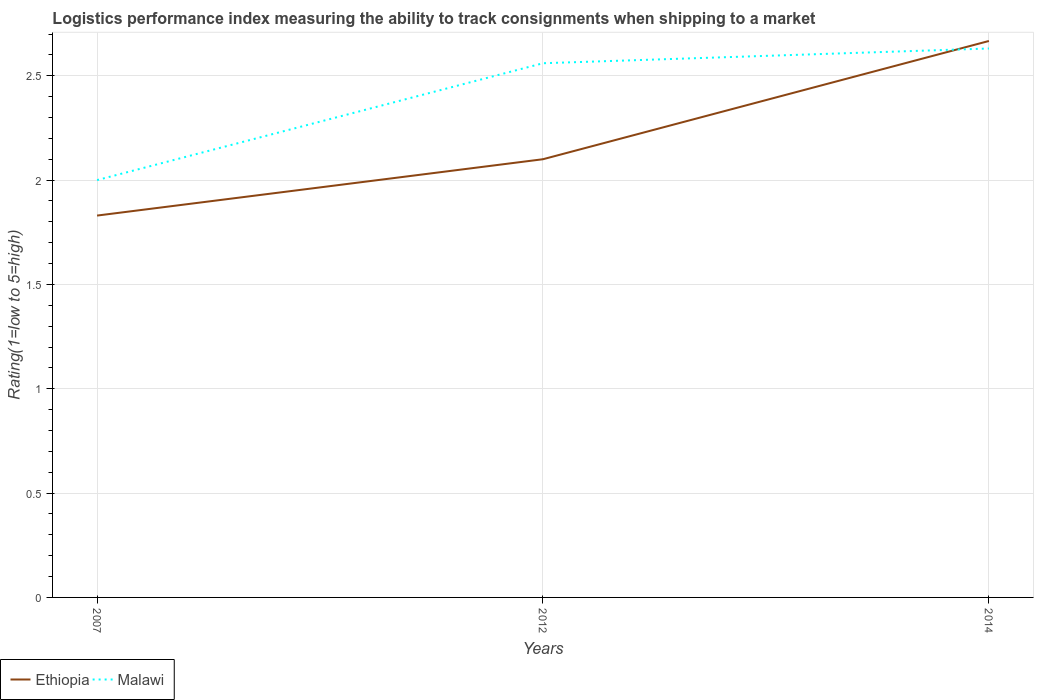Does the line corresponding to Malawi intersect with the line corresponding to Ethiopia?
Offer a very short reply. Yes. Is the number of lines equal to the number of legend labels?
Your answer should be very brief. Yes. Across all years, what is the maximum Logistic performance index in Ethiopia?
Offer a terse response. 1.83. What is the total Logistic performance index in Malawi in the graph?
Your answer should be very brief. -0.56. What is the difference between the highest and the second highest Logistic performance index in Ethiopia?
Your answer should be very brief. 0.84. Is the Logistic performance index in Malawi strictly greater than the Logistic performance index in Ethiopia over the years?
Your answer should be very brief. No. How many lines are there?
Provide a short and direct response. 2. How many years are there in the graph?
Give a very brief answer. 3. What is the difference between two consecutive major ticks on the Y-axis?
Make the answer very short. 0.5. Where does the legend appear in the graph?
Ensure brevity in your answer.  Bottom left. How many legend labels are there?
Make the answer very short. 2. How are the legend labels stacked?
Ensure brevity in your answer.  Horizontal. What is the title of the graph?
Provide a short and direct response. Logistics performance index measuring the ability to track consignments when shipping to a market. What is the label or title of the X-axis?
Keep it short and to the point. Years. What is the label or title of the Y-axis?
Give a very brief answer. Rating(1=low to 5=high). What is the Rating(1=low to 5=high) of Ethiopia in 2007?
Your answer should be very brief. 1.83. What is the Rating(1=low to 5=high) of Malawi in 2007?
Offer a terse response. 2. What is the Rating(1=low to 5=high) in Malawi in 2012?
Ensure brevity in your answer.  2.56. What is the Rating(1=low to 5=high) of Ethiopia in 2014?
Your response must be concise. 2.67. What is the Rating(1=low to 5=high) in Malawi in 2014?
Your response must be concise. 2.63. Across all years, what is the maximum Rating(1=low to 5=high) in Ethiopia?
Offer a terse response. 2.67. Across all years, what is the maximum Rating(1=low to 5=high) in Malawi?
Provide a succinct answer. 2.63. Across all years, what is the minimum Rating(1=low to 5=high) in Ethiopia?
Provide a short and direct response. 1.83. Across all years, what is the minimum Rating(1=low to 5=high) in Malawi?
Your answer should be very brief. 2. What is the total Rating(1=low to 5=high) in Ethiopia in the graph?
Provide a succinct answer. 6.6. What is the total Rating(1=low to 5=high) of Malawi in the graph?
Ensure brevity in your answer.  7.19. What is the difference between the Rating(1=low to 5=high) in Ethiopia in 2007 and that in 2012?
Offer a very short reply. -0.27. What is the difference between the Rating(1=low to 5=high) in Malawi in 2007 and that in 2012?
Provide a succinct answer. -0.56. What is the difference between the Rating(1=low to 5=high) in Ethiopia in 2007 and that in 2014?
Make the answer very short. -0.84. What is the difference between the Rating(1=low to 5=high) in Malawi in 2007 and that in 2014?
Your answer should be very brief. -0.63. What is the difference between the Rating(1=low to 5=high) in Ethiopia in 2012 and that in 2014?
Provide a succinct answer. -0.57. What is the difference between the Rating(1=low to 5=high) of Malawi in 2012 and that in 2014?
Ensure brevity in your answer.  -0.07. What is the difference between the Rating(1=low to 5=high) of Ethiopia in 2007 and the Rating(1=low to 5=high) of Malawi in 2012?
Your answer should be compact. -0.73. What is the difference between the Rating(1=low to 5=high) in Ethiopia in 2007 and the Rating(1=low to 5=high) in Malawi in 2014?
Provide a succinct answer. -0.8. What is the difference between the Rating(1=low to 5=high) in Ethiopia in 2012 and the Rating(1=low to 5=high) in Malawi in 2014?
Ensure brevity in your answer.  -0.53. What is the average Rating(1=low to 5=high) of Ethiopia per year?
Offer a very short reply. 2.2. What is the average Rating(1=low to 5=high) of Malawi per year?
Offer a terse response. 2.4. In the year 2007, what is the difference between the Rating(1=low to 5=high) in Ethiopia and Rating(1=low to 5=high) in Malawi?
Your answer should be very brief. -0.17. In the year 2012, what is the difference between the Rating(1=low to 5=high) in Ethiopia and Rating(1=low to 5=high) in Malawi?
Offer a very short reply. -0.46. In the year 2014, what is the difference between the Rating(1=low to 5=high) of Ethiopia and Rating(1=low to 5=high) of Malawi?
Your answer should be very brief. 0.04. What is the ratio of the Rating(1=low to 5=high) in Ethiopia in 2007 to that in 2012?
Ensure brevity in your answer.  0.87. What is the ratio of the Rating(1=low to 5=high) in Malawi in 2007 to that in 2012?
Ensure brevity in your answer.  0.78. What is the ratio of the Rating(1=low to 5=high) of Ethiopia in 2007 to that in 2014?
Offer a very short reply. 0.69. What is the ratio of the Rating(1=low to 5=high) of Malawi in 2007 to that in 2014?
Make the answer very short. 0.76. What is the ratio of the Rating(1=low to 5=high) of Ethiopia in 2012 to that in 2014?
Provide a succinct answer. 0.79. What is the ratio of the Rating(1=low to 5=high) of Malawi in 2012 to that in 2014?
Keep it short and to the point. 0.97. What is the difference between the highest and the second highest Rating(1=low to 5=high) in Ethiopia?
Provide a short and direct response. 0.57. What is the difference between the highest and the second highest Rating(1=low to 5=high) of Malawi?
Your answer should be very brief. 0.07. What is the difference between the highest and the lowest Rating(1=low to 5=high) of Ethiopia?
Offer a very short reply. 0.84. What is the difference between the highest and the lowest Rating(1=low to 5=high) of Malawi?
Your answer should be very brief. 0.63. 